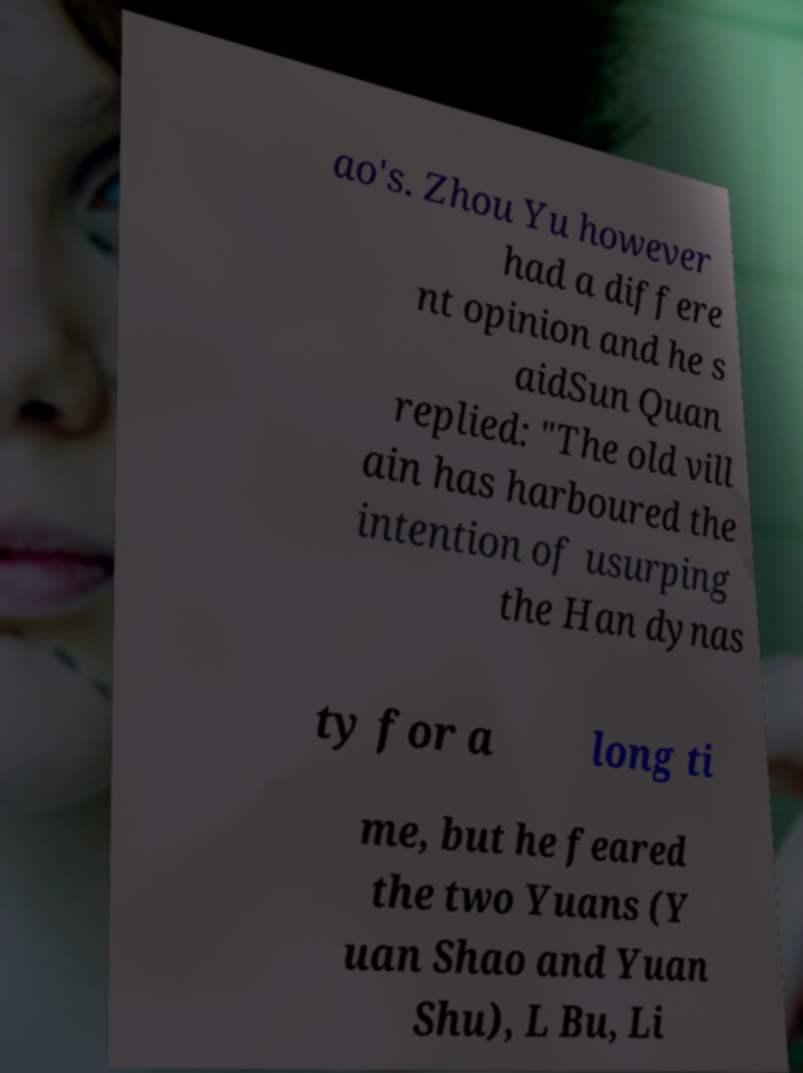Could you extract and type out the text from this image? ao's. Zhou Yu however had a differe nt opinion and he s aidSun Quan replied: "The old vill ain has harboured the intention of usurping the Han dynas ty for a long ti me, but he feared the two Yuans (Y uan Shao and Yuan Shu), L Bu, Li 